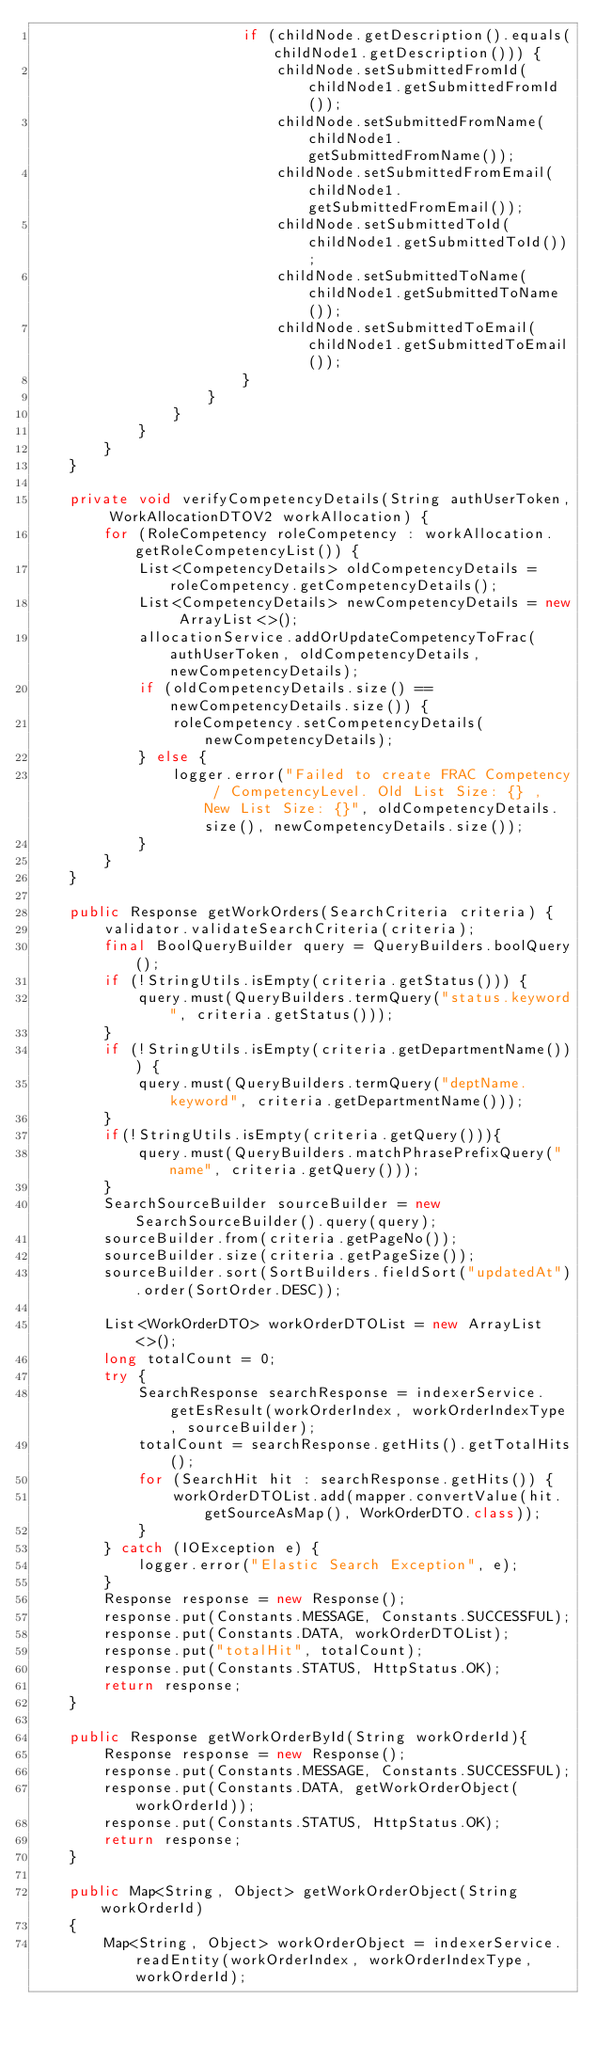<code> <loc_0><loc_0><loc_500><loc_500><_Java_>                        if (childNode.getDescription().equals(childNode1.getDescription())) {
                            childNode.setSubmittedFromId(childNode1.getSubmittedFromId());
                            childNode.setSubmittedFromName(childNode1.getSubmittedFromName());
                            childNode.setSubmittedFromEmail(childNode1.getSubmittedFromEmail());
                            childNode.setSubmittedToId(childNode1.getSubmittedToId());
                            childNode.setSubmittedToName(childNode1.getSubmittedToName());
                            childNode.setSubmittedToEmail(childNode1.getSubmittedToEmail());
                        }
                    }
                }
            }
        }
    }

    private void verifyCompetencyDetails(String authUserToken, WorkAllocationDTOV2 workAllocation) {
        for (RoleCompetency roleCompetency : workAllocation.getRoleCompetencyList()) {
            List<CompetencyDetails> oldCompetencyDetails = roleCompetency.getCompetencyDetails();
            List<CompetencyDetails> newCompetencyDetails = new ArrayList<>();
            allocationService.addOrUpdateCompetencyToFrac(authUserToken, oldCompetencyDetails, newCompetencyDetails);
            if (oldCompetencyDetails.size() == newCompetencyDetails.size()) {
                roleCompetency.setCompetencyDetails(newCompetencyDetails);
            } else {
                logger.error("Failed to create FRAC Competency / CompetencyLevel. Old List Size: {} , New List Size: {}", oldCompetencyDetails.size(), newCompetencyDetails.size());
            }
        }
    }

    public Response getWorkOrders(SearchCriteria criteria) {
        validator.validateSearchCriteria(criteria);
        final BoolQueryBuilder query = QueryBuilders.boolQuery();
        if (!StringUtils.isEmpty(criteria.getStatus())) {
            query.must(QueryBuilders.termQuery("status.keyword", criteria.getStatus()));
        }
        if (!StringUtils.isEmpty(criteria.getDepartmentName())) {
            query.must(QueryBuilders.termQuery("deptName.keyword", criteria.getDepartmentName()));
        }
        if(!StringUtils.isEmpty(criteria.getQuery())){
            query.must(QueryBuilders.matchPhrasePrefixQuery("name", criteria.getQuery()));
        }
        SearchSourceBuilder sourceBuilder = new SearchSourceBuilder().query(query);
        sourceBuilder.from(criteria.getPageNo());
        sourceBuilder.size(criteria.getPageSize());
        sourceBuilder.sort(SortBuilders.fieldSort("updatedAt").order(SortOrder.DESC));

        List<WorkOrderDTO> workOrderDTOList = new ArrayList<>();
        long totalCount = 0;
        try {
            SearchResponse searchResponse = indexerService.getEsResult(workOrderIndex, workOrderIndexType, sourceBuilder);
            totalCount = searchResponse.getHits().getTotalHits();
            for (SearchHit hit : searchResponse.getHits()) {
                workOrderDTOList.add(mapper.convertValue(hit.getSourceAsMap(), WorkOrderDTO.class));
            }
        } catch (IOException e) {
            logger.error("Elastic Search Exception", e);
        }
        Response response = new Response();
        response.put(Constants.MESSAGE, Constants.SUCCESSFUL);
        response.put(Constants.DATA, workOrderDTOList);
        response.put("totalHit", totalCount);
        response.put(Constants.STATUS, HttpStatus.OK);
        return response;
    }

    public Response getWorkOrderById(String workOrderId){
        Response response = new Response();
        response.put(Constants.MESSAGE, Constants.SUCCESSFUL);
        response.put(Constants.DATA, getWorkOrderObject(workOrderId));
        response.put(Constants.STATUS, HttpStatus.OK);
        return response;
    }

    public Map<String, Object> getWorkOrderObject(String workOrderId)
    {
        Map<String, Object> workOrderObject = indexerService.readEntity(workOrderIndex, workOrderIndexType, workOrderId);</code> 